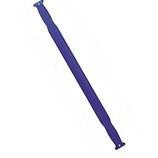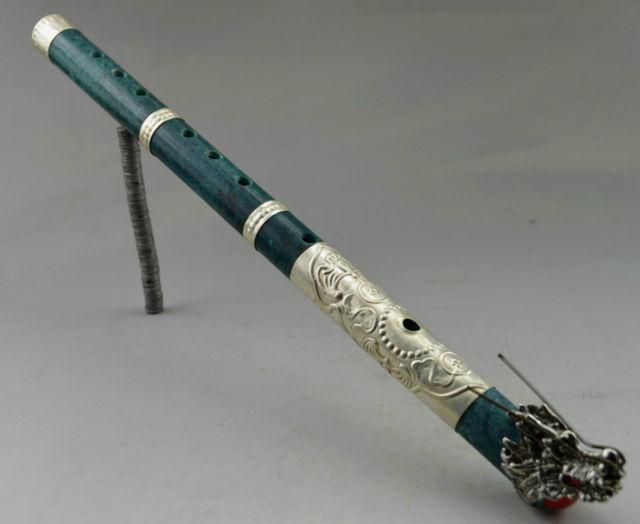The first image is the image on the left, the second image is the image on the right. Considering the images on both sides, is "There are exactly five flutes." valid? Answer yes or no. No. The first image is the image on the left, the second image is the image on the right. Analyze the images presented: Is the assertion "The left image has more flutes than the right image." valid? Answer yes or no. No. 